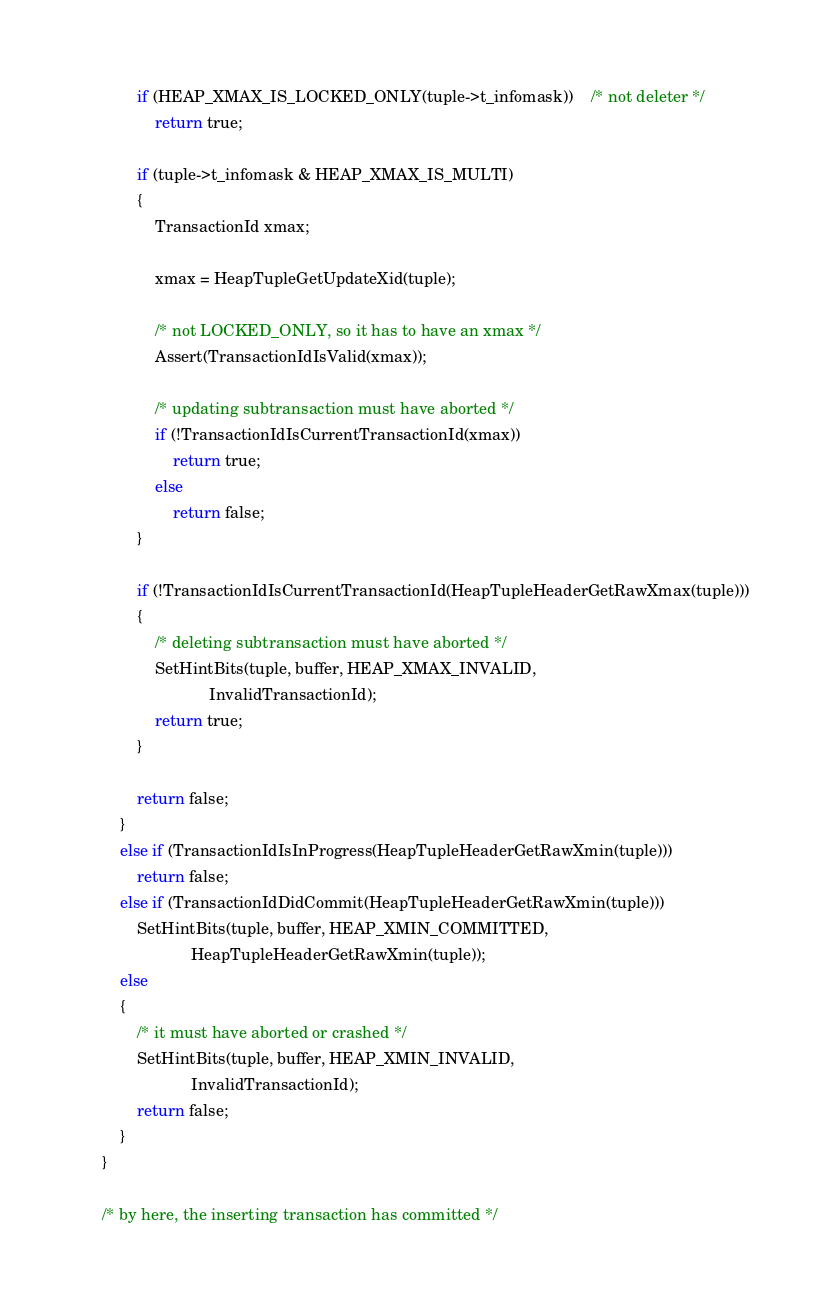<code> <loc_0><loc_0><loc_500><loc_500><_C_>			if (HEAP_XMAX_IS_LOCKED_ONLY(tuple->t_infomask))	/* not deleter */
				return true;

			if (tuple->t_infomask & HEAP_XMAX_IS_MULTI)
			{
				TransactionId xmax;

				xmax = HeapTupleGetUpdateXid(tuple);

				/* not LOCKED_ONLY, so it has to have an xmax */
				Assert(TransactionIdIsValid(xmax));

				/* updating subtransaction must have aborted */
				if (!TransactionIdIsCurrentTransactionId(xmax))
					return true;
				else
					return false;
			}

			if (!TransactionIdIsCurrentTransactionId(HeapTupleHeaderGetRawXmax(tuple)))
			{
				/* deleting subtransaction must have aborted */
				SetHintBits(tuple, buffer, HEAP_XMAX_INVALID,
							InvalidTransactionId);
				return true;
			}

			return false;
		}
		else if (TransactionIdIsInProgress(HeapTupleHeaderGetRawXmin(tuple)))
			return false;
		else if (TransactionIdDidCommit(HeapTupleHeaderGetRawXmin(tuple)))
			SetHintBits(tuple, buffer, HEAP_XMIN_COMMITTED,
						HeapTupleHeaderGetRawXmin(tuple));
		else
		{
			/* it must have aborted or crashed */
			SetHintBits(tuple, buffer, HEAP_XMIN_INVALID,
						InvalidTransactionId);
			return false;
		}
	}

	/* by here, the inserting transaction has committed */
</code> 